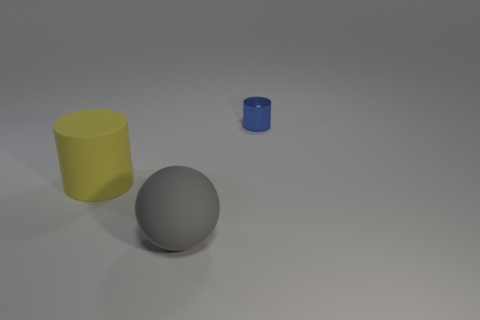Subtract all blue cylinders. How many cylinders are left? 1 Add 3 gray cylinders. How many objects exist? 6 Subtract 2 cylinders. How many cylinders are left? 0 Subtract all spheres. How many objects are left? 2 Subtract all purple cylinders. How many blue spheres are left? 0 Subtract all red shiny cylinders. Subtract all tiny cylinders. How many objects are left? 2 Add 3 yellow rubber cylinders. How many yellow rubber cylinders are left? 4 Add 1 large gray rubber objects. How many large gray rubber objects exist? 2 Subtract 0 red cubes. How many objects are left? 3 Subtract all gray cylinders. Subtract all gray balls. How many cylinders are left? 2 